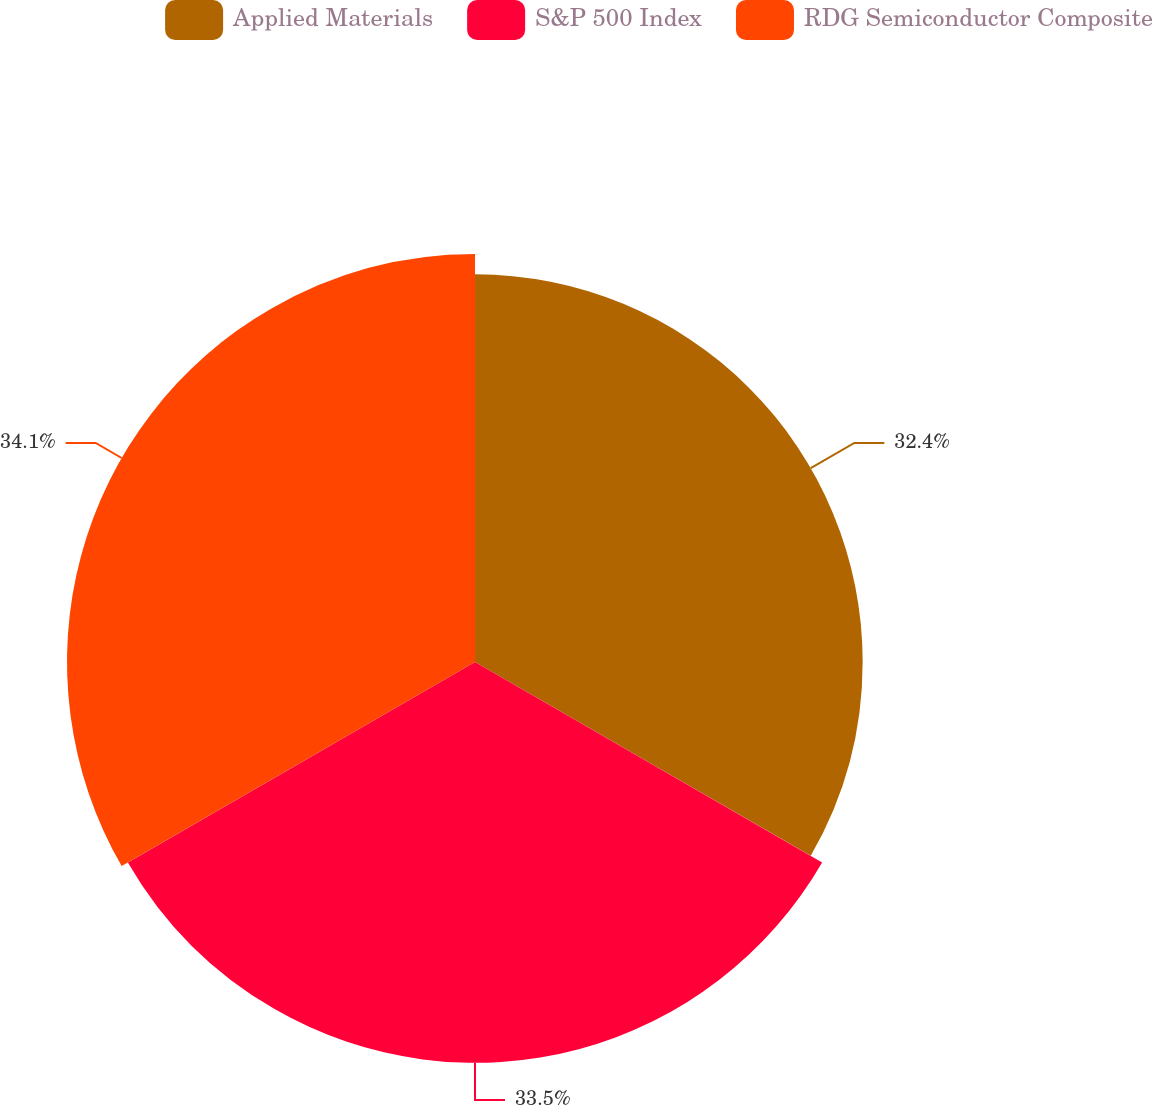<chart> <loc_0><loc_0><loc_500><loc_500><pie_chart><fcel>Applied Materials<fcel>S&P 500 Index<fcel>RDG Semiconductor Composite<nl><fcel>32.4%<fcel>33.5%<fcel>34.1%<nl></chart> 